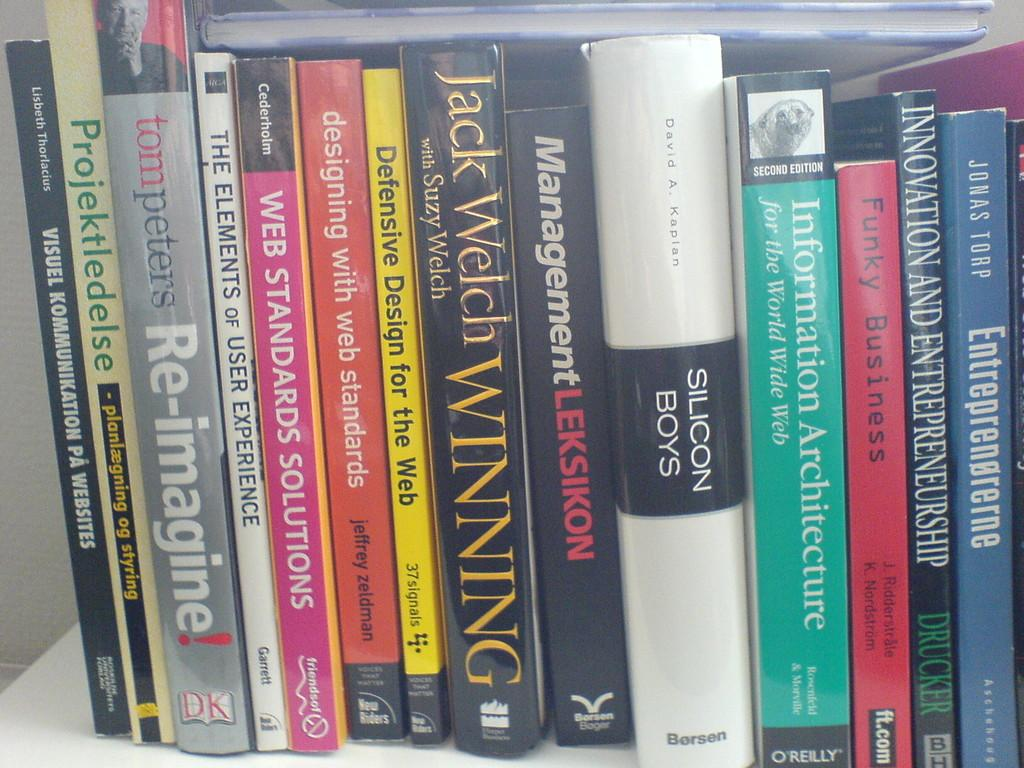<image>
Present a compact description of the photo's key features. A collection of books includes many about web design. 